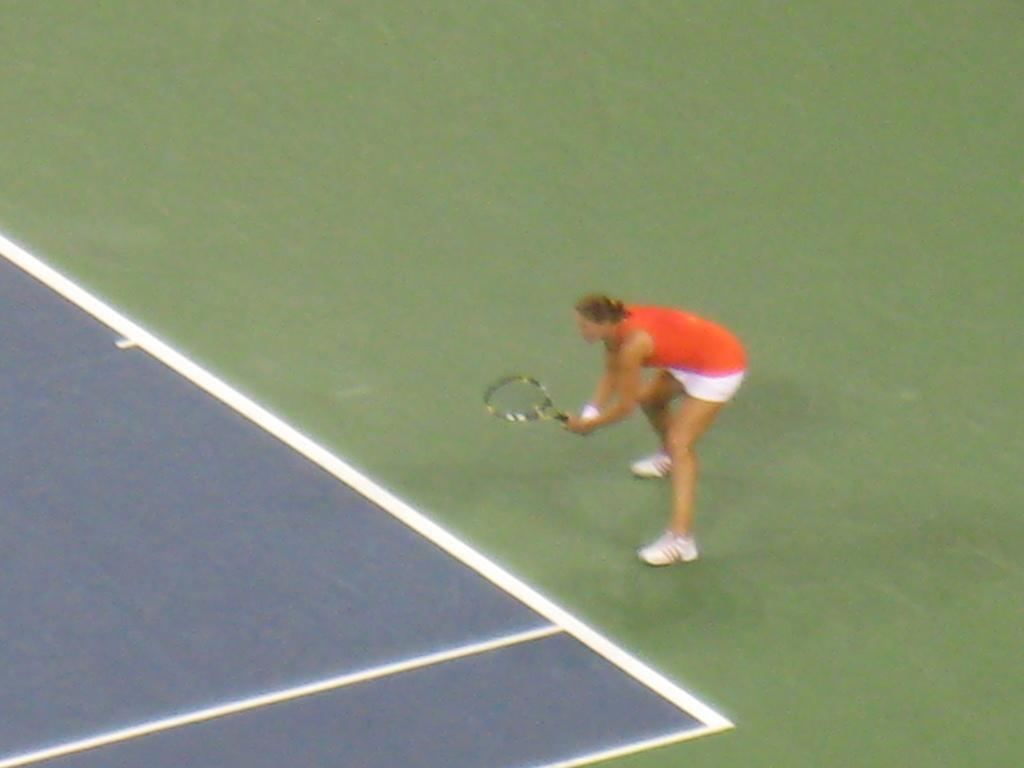What is the person in the image doing? The person is playing tennis. What object is the person holding in the image? The person is holding a tennis racket with both hands. How is the person positioned while playing tennis? The person is standing in a squatting position. How long does it take for the icicle to form in the image? There is no icicle present in the image, so it is not possible to determine how long it would take to form. 